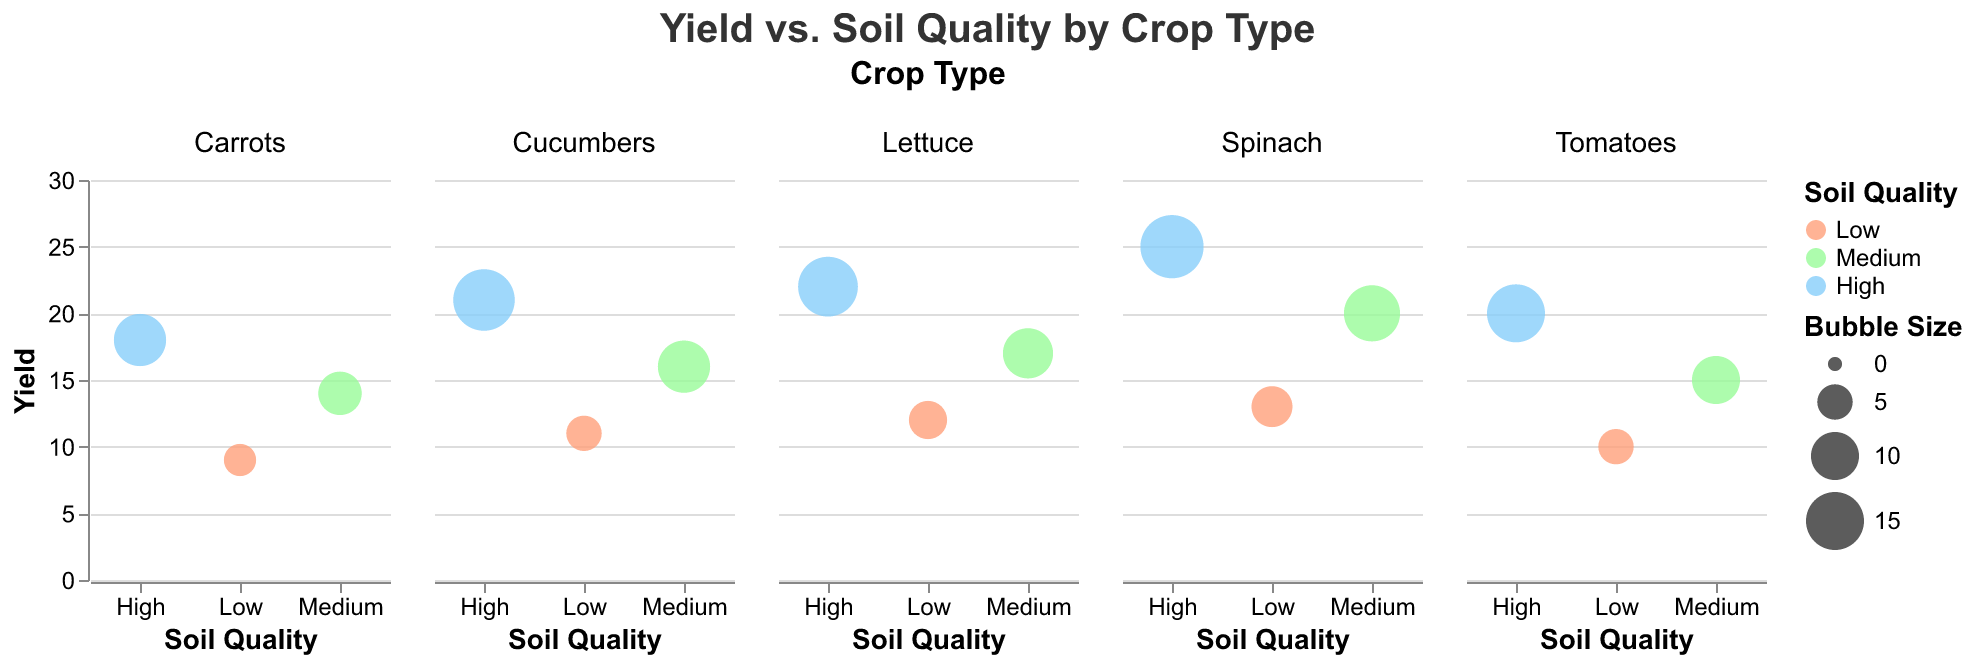What is the title of the figure? The title is usually found at the top of the figure, clearly stating the subject. Here, it reads "Yield vs. Soil Quality by Crop Type."
Answer: Yield vs. Soil Quality by Crop Type Which crop shows the highest yield? To find the highest yield, look at the crop type with the highest value on the y-axis, which is "Spinach" with a yield of 25.
Answer: Spinach What soil quality is associated with the highest yield for Cucumbers? Check the y-axis value for Cucumbers and identify the corresponding x-axis value; Cucumbers has the highest yield (21) associated with "High" soil quality.
Answer: High How many data points represent each crop type? Each crop type has three data points for Low, Medium, and High soil quality. The figure shows subplots for Tomatoes, Carrots, Lettuce, Spinach, and Cucumbers, all having three points each.
Answer: 3 Which crop shows the smallest bubble size and what is the soil quality and yield for this data point? The smallest bubble size indicates the smallest value for the "Bubble_Size" field. Carrots with Low soil quality has the smallest bubble size (4) and a yield of 9.
Answer: Carrots, Low, 9 Does soil quality positively affect yield across all crop types? To determine this, observe the trend in the yield values for Low, Medium, and High soil quality across all crop types. Yield increases with soil quality across all crops: Tomatoes (10 to 20), Carrots (9 to 18), Lettuce (12 to 22), Spinach (13 to 25), and Cucumbers (11 to 21).
Answer: Yes Which crop exhibits the largest difference in yield between High and Low soil quality? Calculate the yield difference between High and Low soil quality for each crop and compare. Spinach shows the largest difference: High (25) - Low (13) = 12.
Answer: Spinach For which crop does medium soil quality yield exceed the low soil quality yield by the greatest amount? Find the yield differences between Medium and Low soil quality for each crop and identify the maximum. Spinach has the largest difference: Medium (20) - Low (13) = 7.
Answer: Spinach Are there any crops where yield is higher for medium soil quality than high soil quality? Compare the yield values for Medium and High soil quality for each crop. No crop has higher yield for Medium soil quality than High soil quality.
Answer: No What is the average yield for Lettuce across all soil qualities? Sum the yield values for Lettuce (High: 22, Medium: 17, Low: 12) and divide by 3. The average yield = (22 + 17 + 12) / 3 = 17.
Answer: 17 